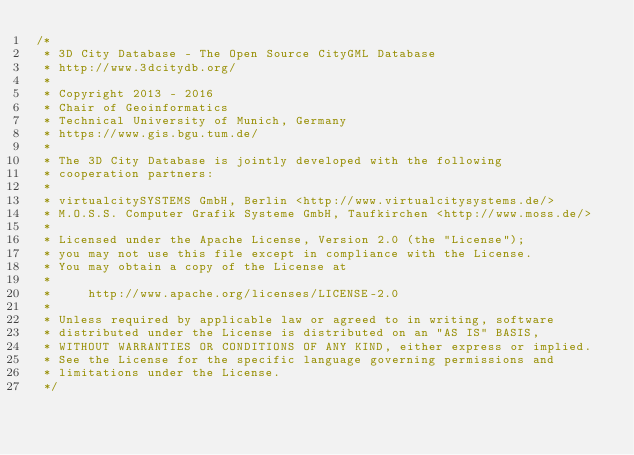Convert code to text. <code><loc_0><loc_0><loc_500><loc_500><_Java_>/*
 * 3D City Database - The Open Source CityGML Database
 * http://www.3dcitydb.org/
 * 
 * Copyright 2013 - 2016
 * Chair of Geoinformatics
 * Technical University of Munich, Germany
 * https://www.gis.bgu.tum.de/
 * 
 * The 3D City Database is jointly developed with the following
 * cooperation partners:
 * 
 * virtualcitySYSTEMS GmbH, Berlin <http://www.virtualcitysystems.de/>
 * M.O.S.S. Computer Grafik Systeme GmbH, Taufkirchen <http://www.moss.de/>
 * 
 * Licensed under the Apache License, Version 2.0 (the "License");
 * you may not use this file except in compliance with the License.
 * You may obtain a copy of the License at
 * 
 *     http://www.apache.org/licenses/LICENSE-2.0
 *     
 * Unless required by applicable law or agreed to in writing, software
 * distributed under the License is distributed on an "AS IS" BASIS,
 * WITHOUT WARRANTIES OR CONDITIONS OF ANY KIND, either express or implied.
 * See the License for the specific language governing permissions and
 * limitations under the License.
 */</code> 